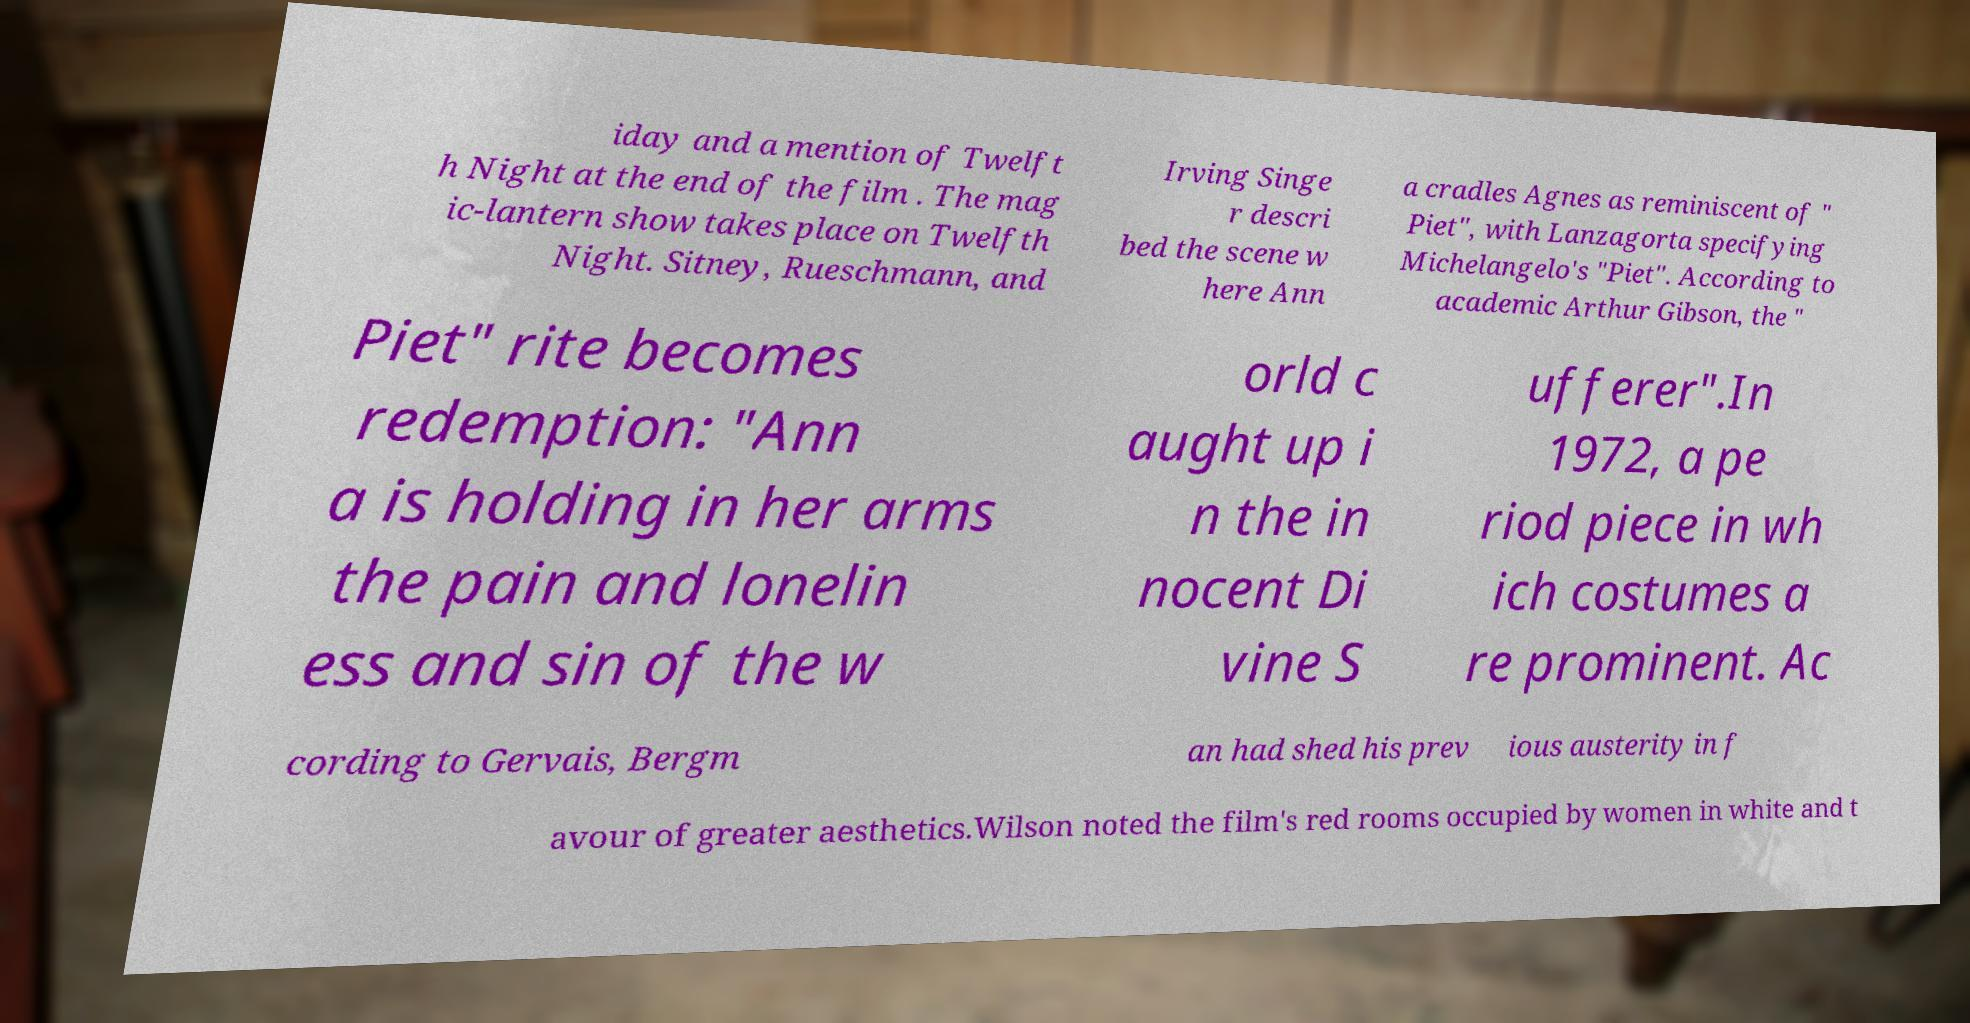Can you read and provide the text displayed in the image?This photo seems to have some interesting text. Can you extract and type it out for me? iday and a mention of Twelft h Night at the end of the film . The mag ic-lantern show takes place on Twelfth Night. Sitney, Rueschmann, and Irving Singe r descri bed the scene w here Ann a cradles Agnes as reminiscent of " Piet", with Lanzagorta specifying Michelangelo's "Piet". According to academic Arthur Gibson, the " Piet" rite becomes redemption: "Ann a is holding in her arms the pain and lonelin ess and sin of the w orld c aught up i n the in nocent Di vine S ufferer".In 1972, a pe riod piece in wh ich costumes a re prominent. Ac cording to Gervais, Bergm an had shed his prev ious austerity in f avour of greater aesthetics.Wilson noted the film's red rooms occupied by women in white and t 